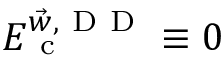<formula> <loc_0><loc_0><loc_500><loc_500>E _ { c } ^ { \vec { w } , { D D } } \equiv 0</formula> 